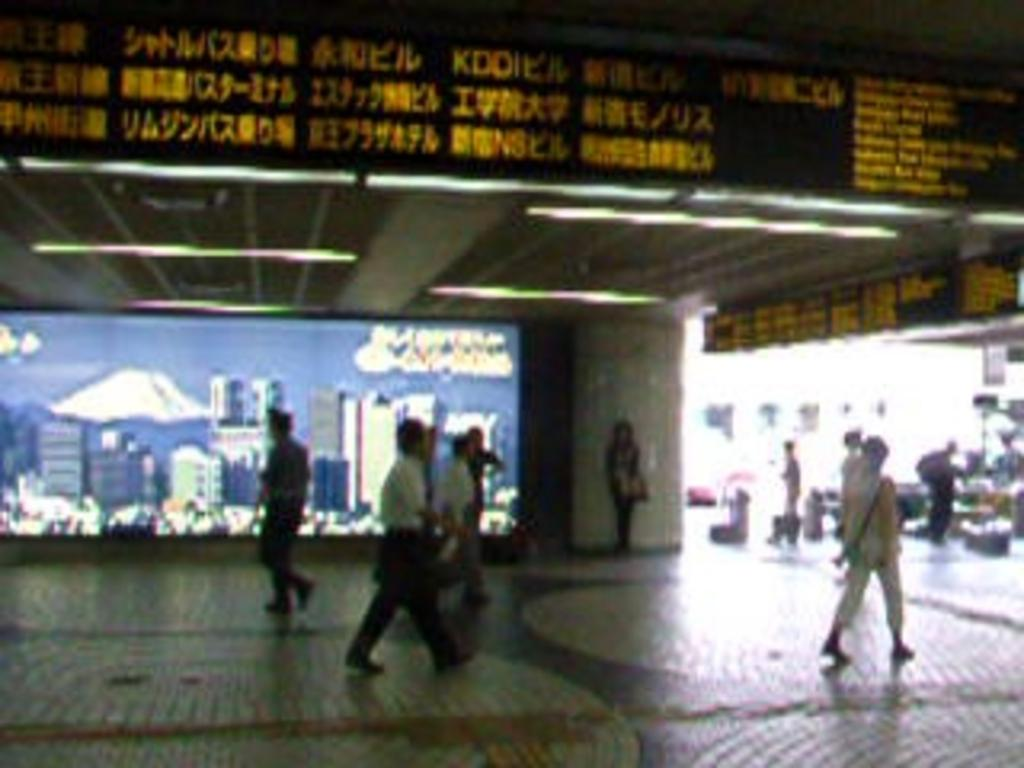What are the people in the image doing? There is a group of people walking in the image. What can be seen on the wall in the image? There is a name board and a poster in the image. What type of lighting is present in the image? There are tube lights hanging from the roof in the image. What architectural feature is present in the image? There is a pillar in the image. What color of ink is being used on the poster in the image? There is no information about the color of ink used on the poster in the image. What type of alarm is present in the image? There is no alarm present in the image. 